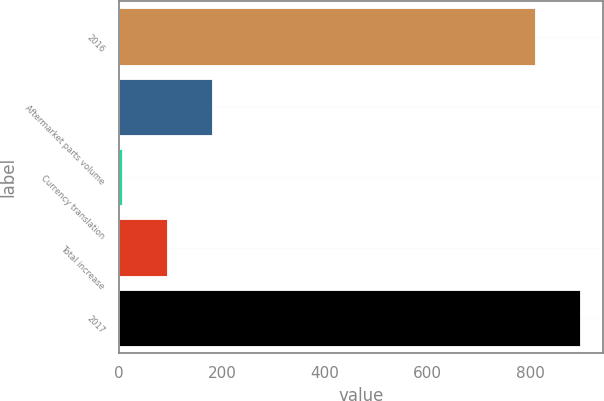Convert chart. <chart><loc_0><loc_0><loc_500><loc_500><bar_chart><fcel>2016<fcel>Aftermarket parts volume<fcel>Currency translation<fcel>Total increase<fcel>2017<nl><fcel>810<fcel>180.48<fcel>4.9<fcel>92.69<fcel>897.79<nl></chart> 